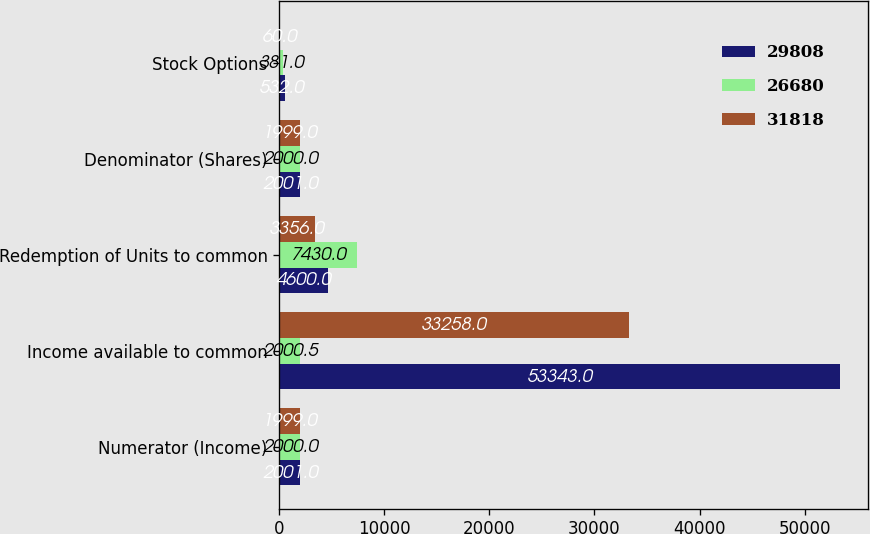Convert chart to OTSL. <chart><loc_0><loc_0><loc_500><loc_500><stacked_bar_chart><ecel><fcel>Numerator (Income)<fcel>Income available to common<fcel>Redemption of Units to common<fcel>Denominator (Shares)<fcel>Stock Options<nl><fcel>29808<fcel>2001<fcel>53343<fcel>4600<fcel>2001<fcel>532<nl><fcel>26680<fcel>2000<fcel>2000.5<fcel>7430<fcel>2000<fcel>381<nl><fcel>31818<fcel>1999<fcel>33258<fcel>3356<fcel>1999<fcel>60<nl></chart> 